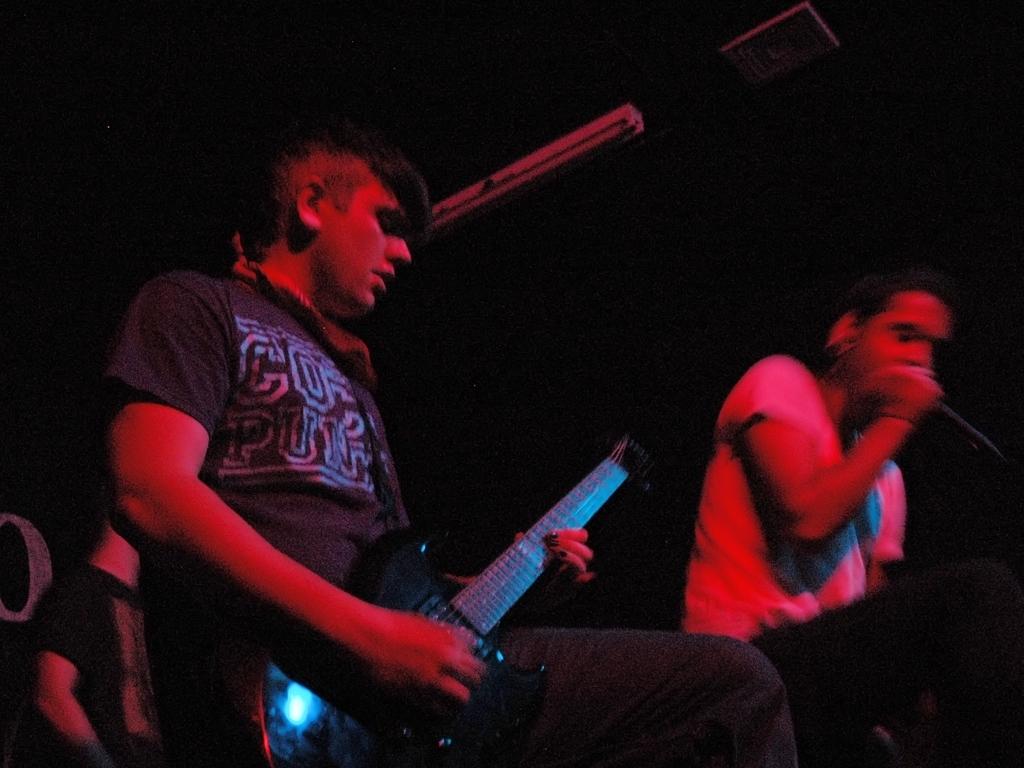Can you describe the emotions or mood conveyed by the musicians in this image? While the detail is somewhat obscured due to the image quality, the musicians present a sense of intensity and passion, which is often characteristic of live performances. The guitarist appears focused and immersed in playing, suggesting dedication to the craft, while the blurry capture of the vocalist conveys a sense of movement and energetic performance. 